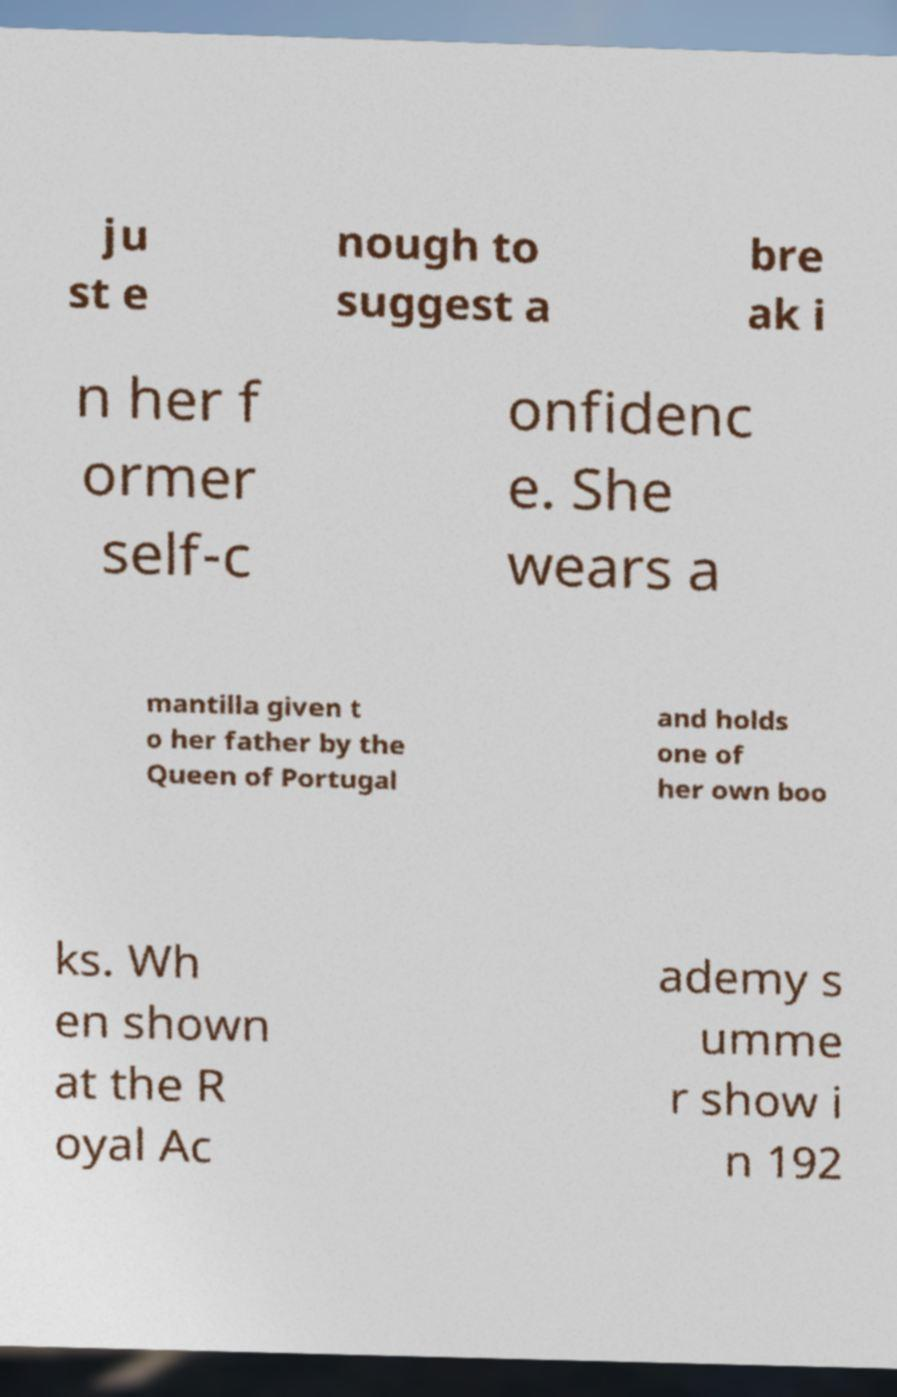For documentation purposes, I need the text within this image transcribed. Could you provide that? ju st e nough to suggest a bre ak i n her f ormer self-c onfidenc e. She wears a mantilla given t o her father by the Queen of Portugal and holds one of her own boo ks. Wh en shown at the R oyal Ac ademy s umme r show i n 192 